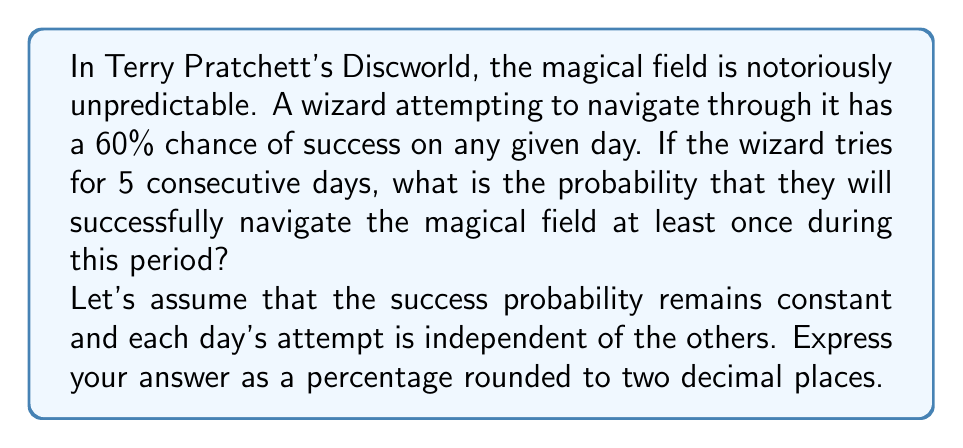Show me your answer to this math problem. To solve this problem, we'll use the concept of probability for independent events.

1) First, let's consider the probability of failure for a single day:
   $P(\text{failure for one day}) = 1 - P(\text{success for one day}) = 1 - 0.60 = 0.40$

2) Now, for the wizard to fail on all 5 days, they would need to fail each day independently:
   $P(\text{fail all 5 days}) = 0.40 \times 0.40 \times 0.40 \times 0.40 \times 0.40 = 0.40^5$

3) We can calculate this:
   $0.40^5 = 0.01024$

4) The probability of success on at least one day is the opposite of failing on all days:
   $P(\text{success at least once}) = 1 - P(\text{fail all 5 days})$
   $= 1 - 0.01024 = 0.98976$

5) Convert to a percentage:
   $0.98976 \times 100\% = 98.976\%$

6) Rounding to two decimal places:
   $98.98\%$

This high probability reflects the cumulative effect of multiple attempts, even when each individual attempt has a relatively modest chance of success.
Answer: $98.98\%$ 